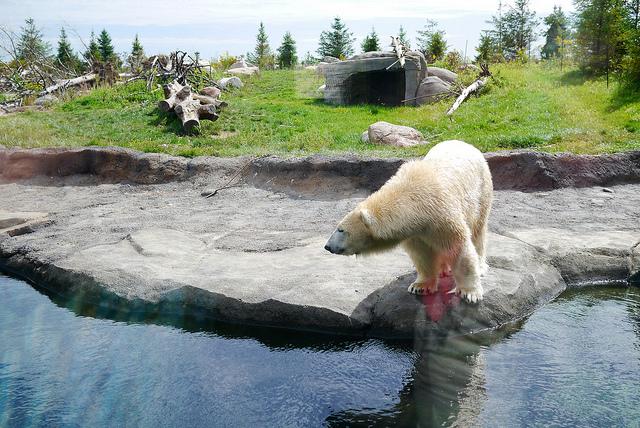Was this photo taken through glass?
Concise answer only. Yes. Is there a cave?
Keep it brief. Yes. What is he on?
Quick response, please. Rock. IS the bear in its natural habitat?
Concise answer only. No. What type of trees are in the background?
Keep it brief. Pine. Does this bear like the water?
Short answer required. Yes. What living being do you see in the image?
Write a very short answer. Polar bear. 